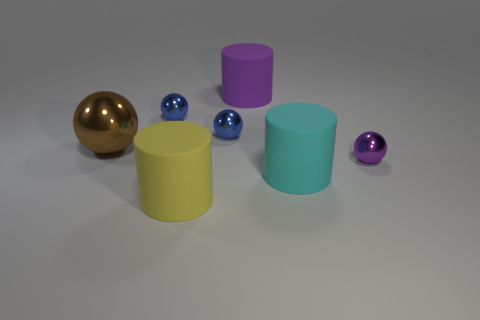How many spheres are present in the scene? There are three spheres in the scene; one large gold sphere on the left and two smaller spheres, one blue and one purple, near the central cylinder. 